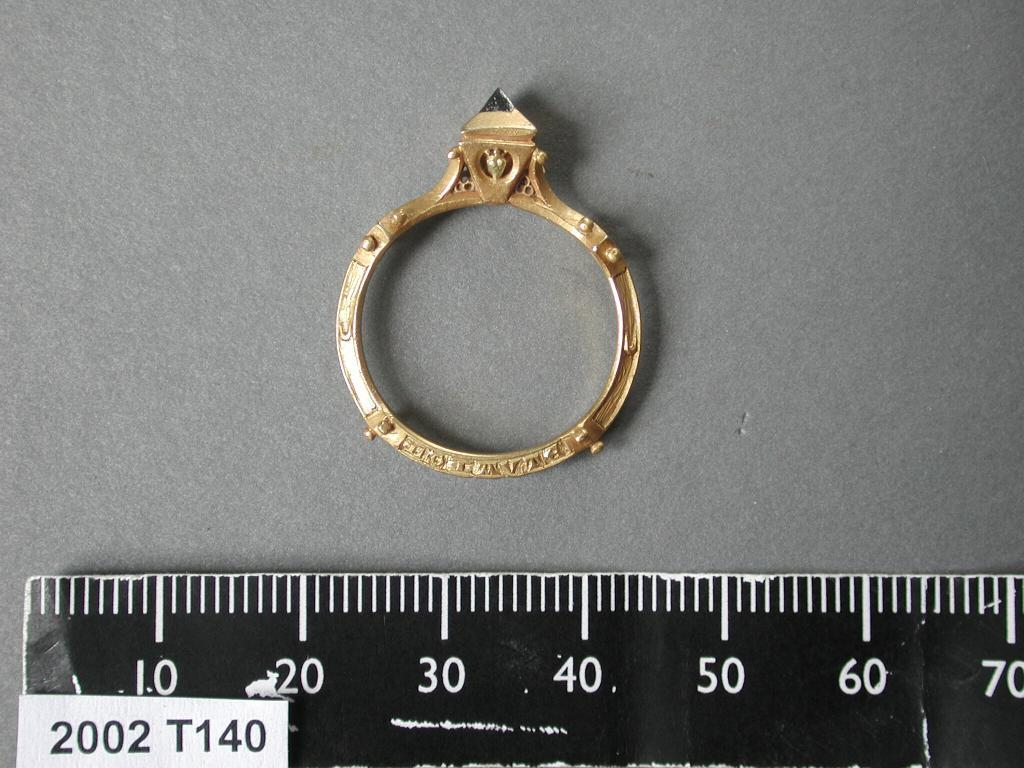<image>
Render a clear and concise summary of the photo. A ring with a gem on it is rested next to a ruler measuring it's size. 